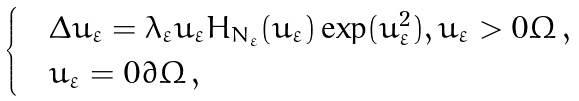<formula> <loc_0><loc_0><loc_500><loc_500>\begin{cases} & \Delta u _ { \varepsilon } = \lambda _ { \varepsilon } u _ { \varepsilon } H _ { N _ { \varepsilon } } ( u _ { \varepsilon } ) \exp ( u _ { \varepsilon } ^ { 2 } ) , u _ { \varepsilon } > 0 \Omega \, , \\ & u _ { \varepsilon } = 0 \partial \Omega \, , \end{cases}</formula> 